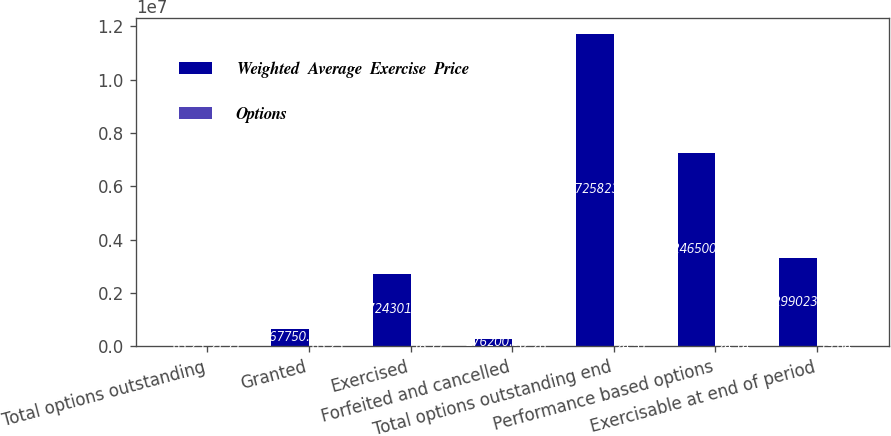Convert chart to OTSL. <chart><loc_0><loc_0><loc_500><loc_500><stacked_bar_chart><ecel><fcel>Total options outstanding<fcel>Granted<fcel>Exercised<fcel>Forfeited and cancelled<fcel>Total options outstanding end<fcel>Performance based options<fcel>Exercisable at end of period<nl><fcel>Weighted  Average  Exercise  Price<fcel>63.23<fcel>667750<fcel>2.7243e+06<fcel>276200<fcel>1.17258e+07<fcel>7.2465e+06<fcel>3.29902e+06<nl><fcel>Options<fcel>21.71<fcel>63.23<fcel>18.77<fcel>32.26<fcel>24.51<fcel>24.14<fcel>19.64<nl></chart> 